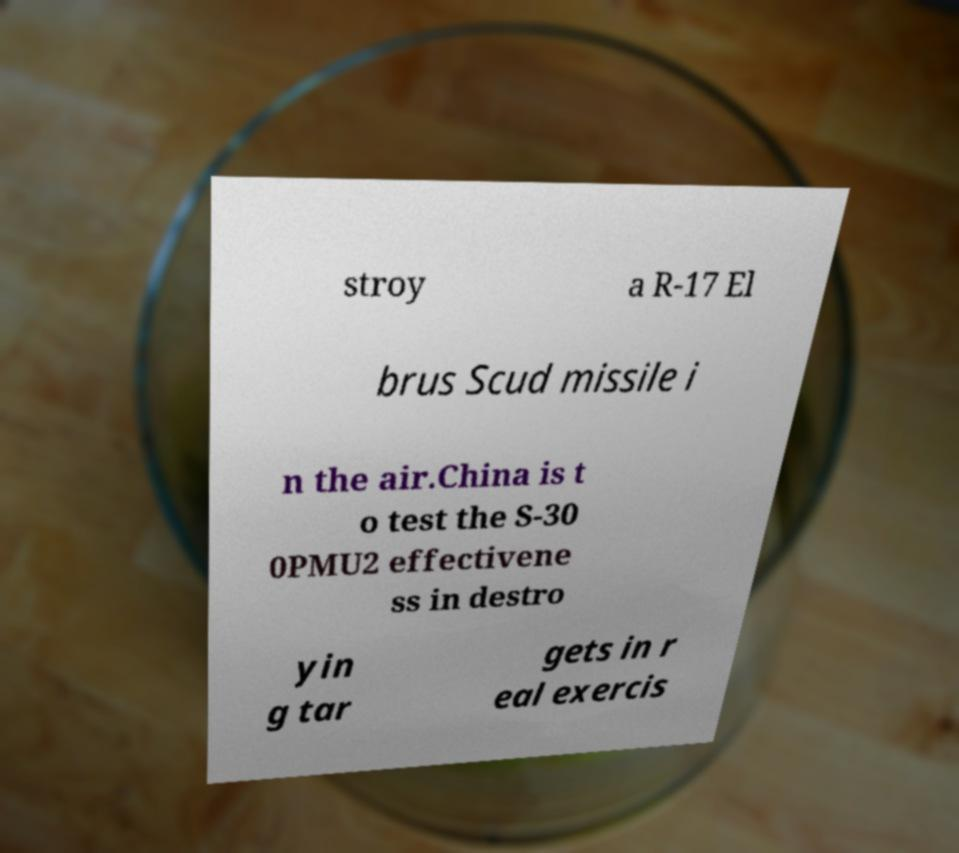Can you read and provide the text displayed in the image?This photo seems to have some interesting text. Can you extract and type it out for me? stroy a R-17 El brus Scud missile i n the air.China is t o test the S-30 0PMU2 effectivene ss in destro yin g tar gets in r eal exercis 